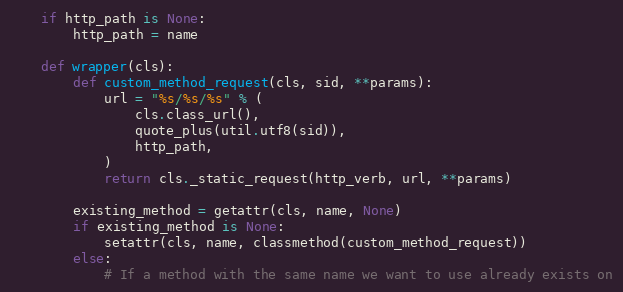<code> <loc_0><loc_0><loc_500><loc_500><_Python_>    if http_path is None:
        http_path = name

    def wrapper(cls):
        def custom_method_request(cls, sid, **params):
            url = "%s/%s/%s" % (
                cls.class_url(),
                quote_plus(util.utf8(sid)),
                http_path,
            )
            return cls._static_request(http_verb, url, **params)

        existing_method = getattr(cls, name, None)
        if existing_method is None:
            setattr(cls, name, classmethod(custom_method_request))
        else:
            # If a method with the same name we want to use already exists on</code> 